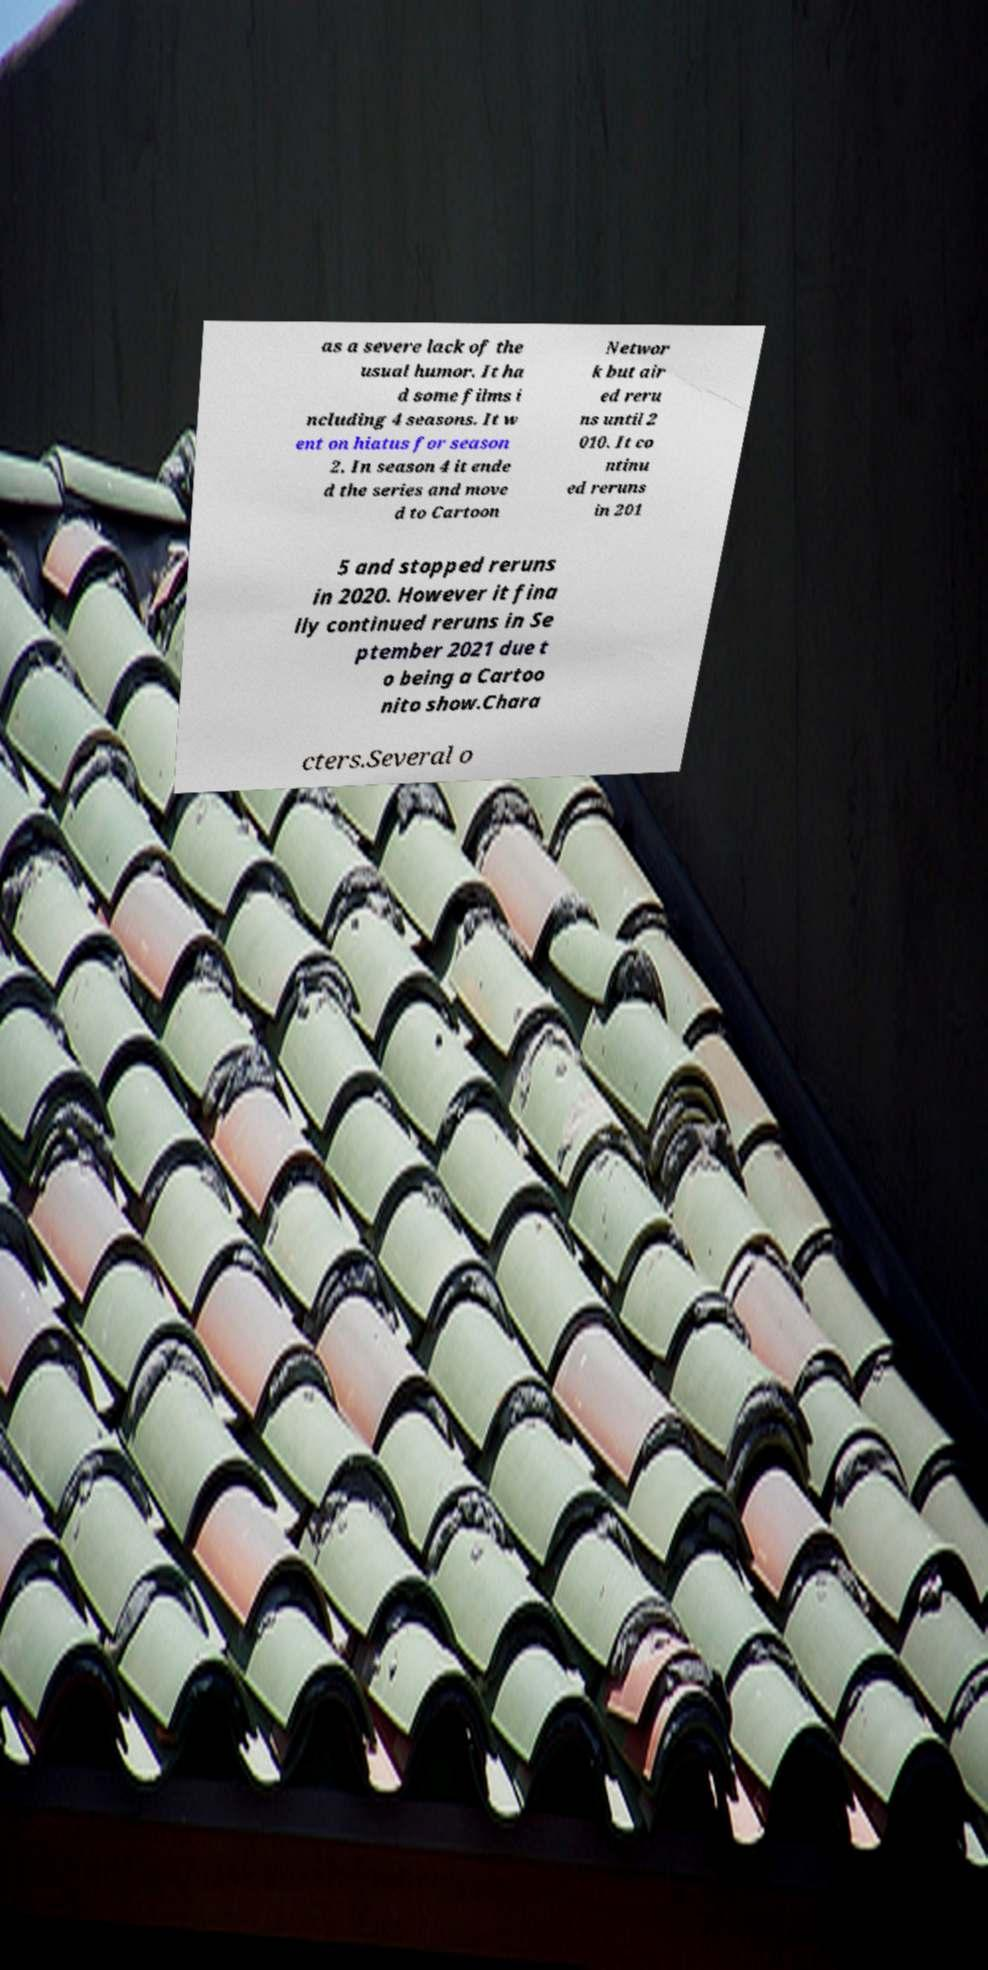There's text embedded in this image that I need extracted. Can you transcribe it verbatim? as a severe lack of the usual humor. It ha d some films i ncluding 4 seasons. It w ent on hiatus for season 2. In season 4 it ende d the series and move d to Cartoon Networ k but air ed reru ns until 2 010. It co ntinu ed reruns in 201 5 and stopped reruns in 2020. However it fina lly continued reruns in Se ptember 2021 due t o being a Cartoo nito show.Chara cters.Several o 